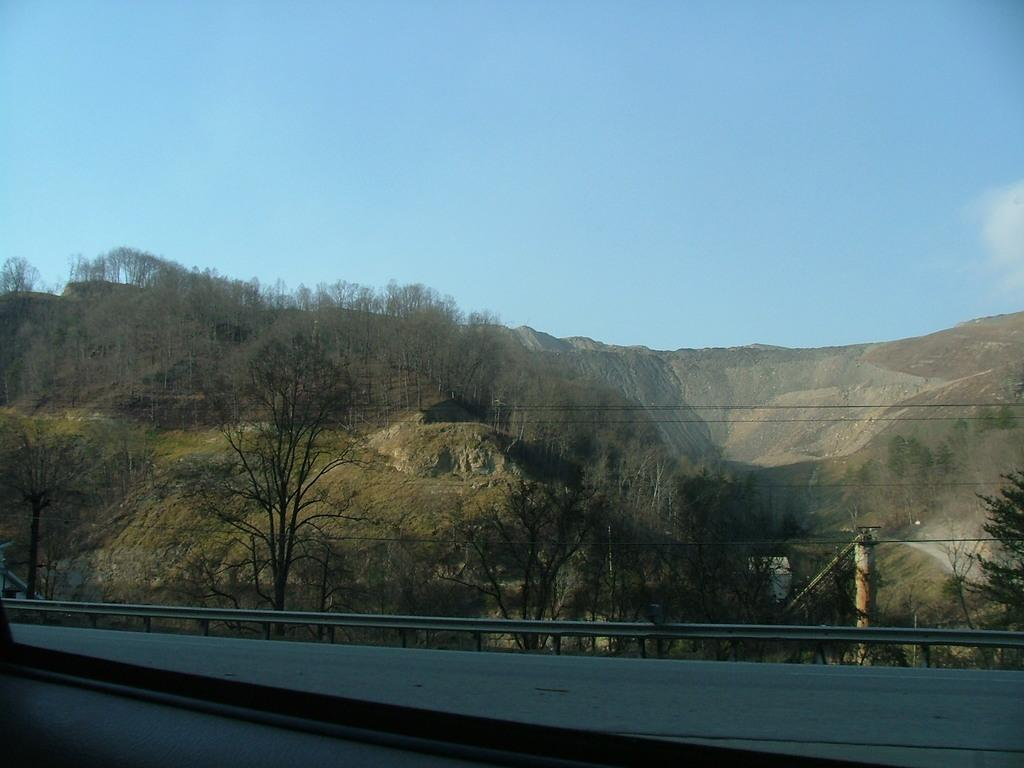What type of vegetation is present in the image? There are many trees in the image. What geographical feature can be seen in the image? There is a mountain in the image. What type of ground cover is visible in the image? There is grass in the image. What man-made structures are present in the image? There is an electric pole and electric wires in the image. What is the color of the sky in the image? The sky is pale blue in the image. What type of barrier is present in the image? There is a barrier in the image. Can you see a cow attempting to unscrew the electric pole in the image? No, there is no cow or any attempt to unscrew the electric pole in the image. 